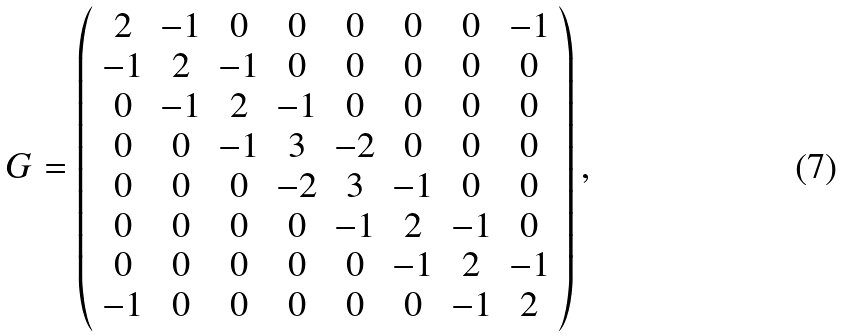<formula> <loc_0><loc_0><loc_500><loc_500>G = \left ( \begin{array} { c c c c c c c c } 2 & - 1 & 0 & 0 & 0 & 0 & 0 & - 1 \\ - 1 & 2 & - 1 & 0 & 0 & 0 & 0 & 0 \\ 0 & - 1 & 2 & - 1 & 0 & 0 & 0 & 0 \\ 0 & 0 & - 1 & 3 & - 2 & 0 & 0 & 0 \\ 0 & 0 & 0 & - 2 & 3 & - 1 & 0 & 0 \\ 0 & 0 & 0 & 0 & - 1 & 2 & - 1 & 0 \\ 0 & 0 & 0 & 0 & 0 & - 1 & 2 & - 1 \\ - 1 & 0 & 0 & 0 & 0 & 0 & - 1 & 2 \end{array} \right ) ,</formula> 